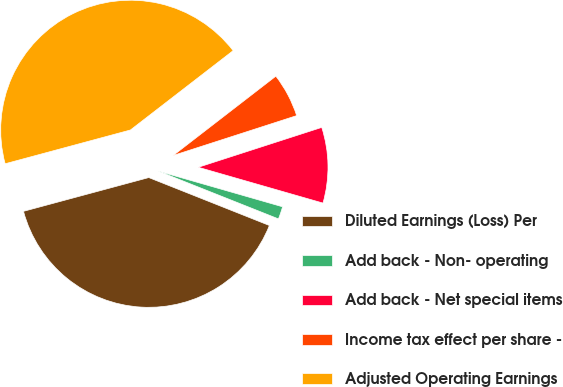Convert chart. <chart><loc_0><loc_0><loc_500><loc_500><pie_chart><fcel>Diluted Earnings (Loss) Per<fcel>Add back - Non- operating<fcel>Add back - Net special items<fcel>Income tax effect per share -<fcel>Adjusted Operating Earnings<nl><fcel>39.79%<fcel>1.57%<fcel>9.42%<fcel>5.5%<fcel>43.72%<nl></chart> 